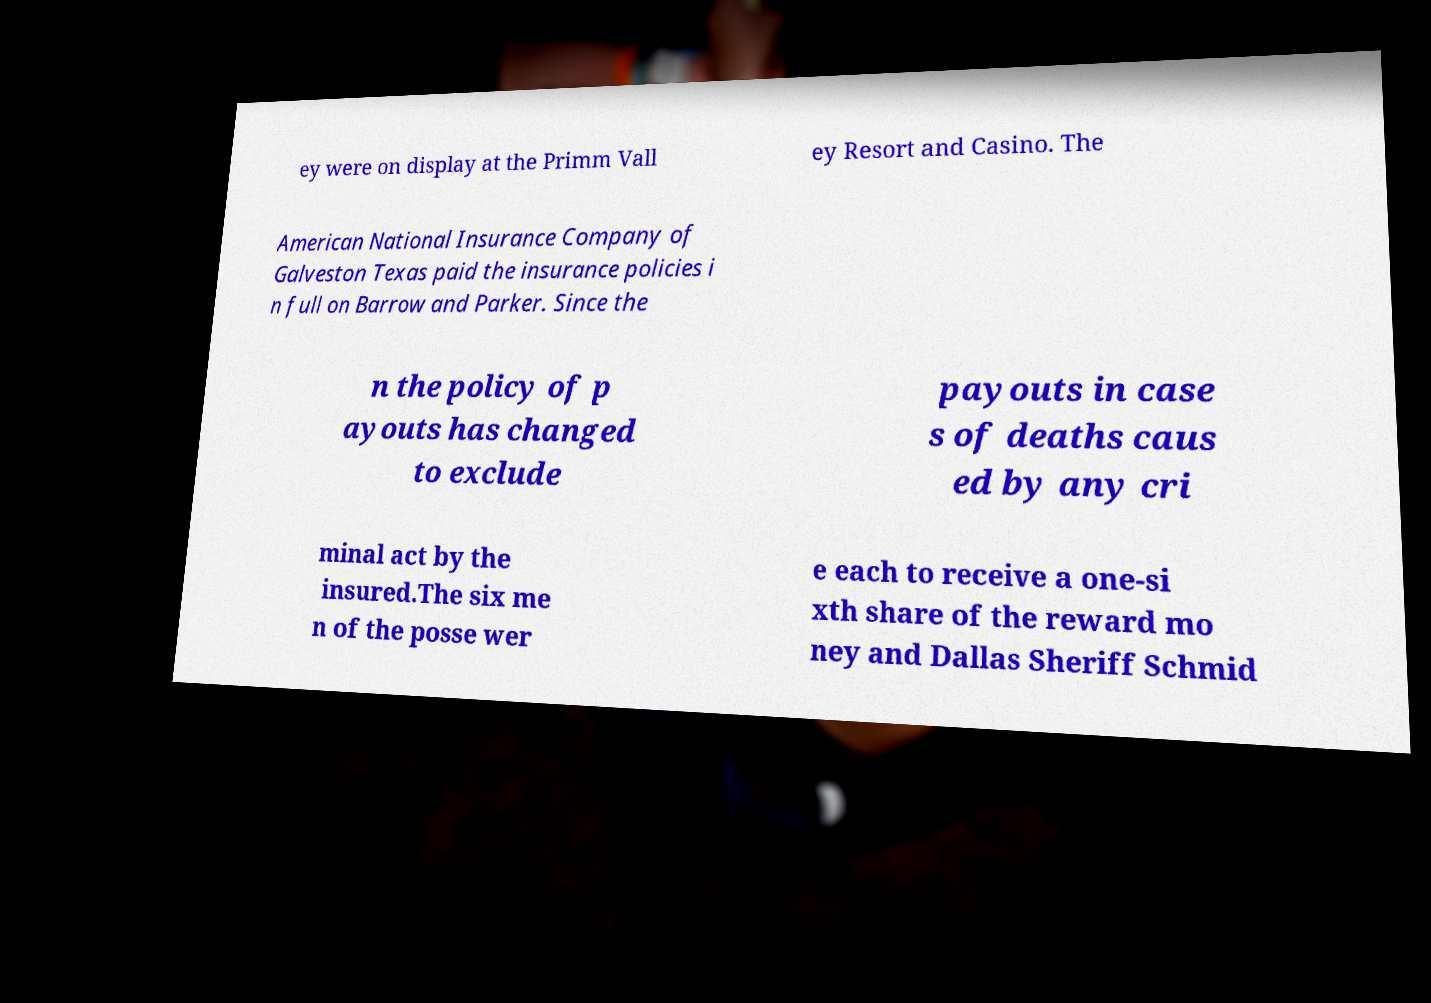There's text embedded in this image that I need extracted. Can you transcribe it verbatim? ey were on display at the Primm Vall ey Resort and Casino. The American National Insurance Company of Galveston Texas paid the insurance policies i n full on Barrow and Parker. Since the n the policy of p ayouts has changed to exclude payouts in case s of deaths caus ed by any cri minal act by the insured.The six me n of the posse wer e each to receive a one-si xth share of the reward mo ney and Dallas Sheriff Schmid 